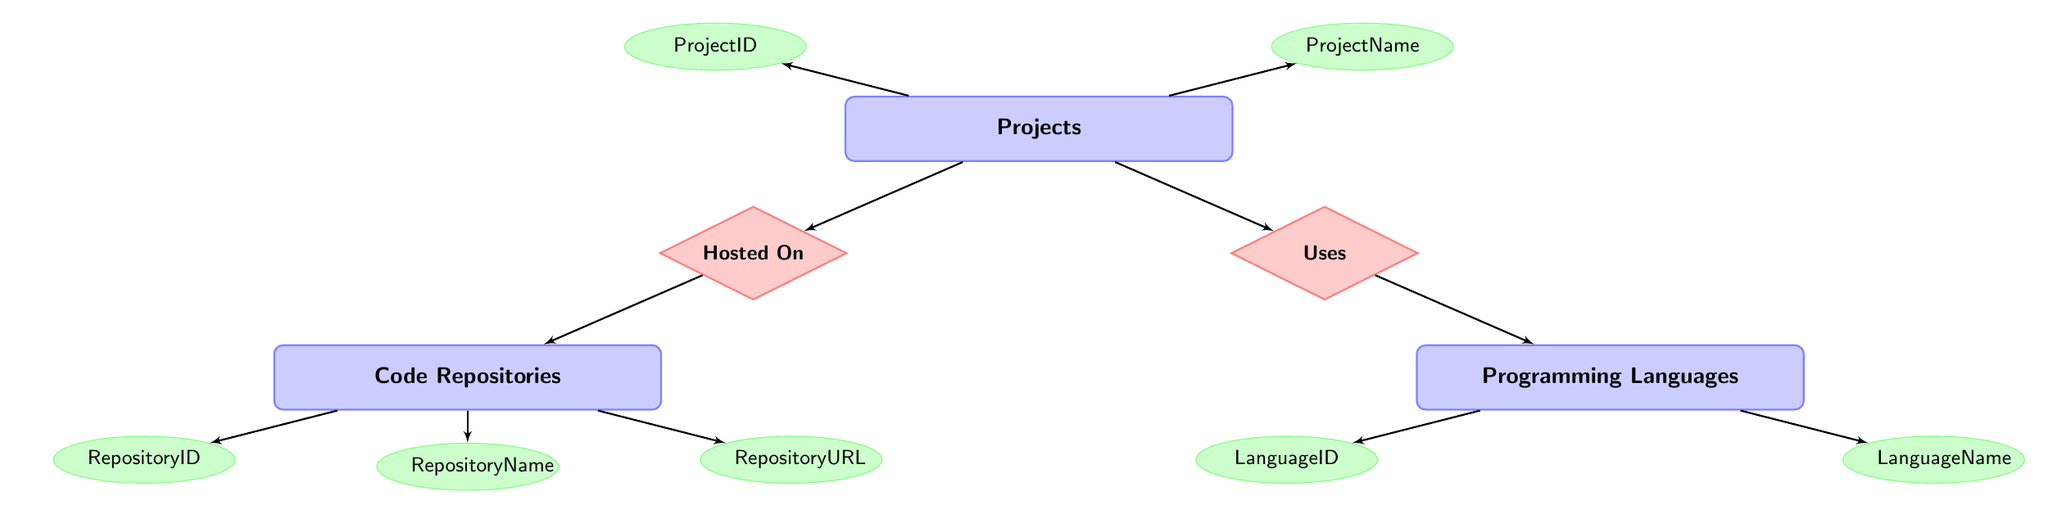What is the ProjectID of the "To-Do List" project? To find the ProjectID for the "To-Do List," I look at the "Projects" entity and find the "ProjectName." The entry for "To-Do List" has a ProjectID of 3.
Answer: 3 Which Programming Language is used in the "Weather App"? To answer this, I refer to the "ProjectsProgrammingLanguages" relationship. I find the entry with ProjectID 2 (which corresponds to "Weather App") and check its associated LanguageID, which is 2. Then, I look in the "Programming Languages" entity for LanguageID 2, finding that it corresponds to "JavaScript."
Answer: JavaScript Where is the "2D RPG Game" project hosted? I look at the "ProjectsCodeRepositories" relationship for ProjectID 1, which is the identifier for the "2D RPG Game." The associated RepositoryID is 1. Then, I check the "Code Repositories" entity and find that RepositoryID 1 corresponds to "GitHub."
Answer: GitHub What Programming Language is used in the project hosted on GitLab? First, I find the repository hosted on GitLab in the "Code Repositories" entity, which has RepositoryID 3. Next, I check the "ProjectsCodeRepositories" relationship for RepositoryID 3 to find the associated ProjectID, which is 3. Finally, I look into the "ProjectsProgrammingLanguages" relationship for ProjectID 3 and see that it uses LanguageID 1, which corresponds to "Python" in the "Programming Languages" entity.
Answer: Python How many entities are represented in this ERD? The entities include "Projects," "Programming Languages," and "Code Repositories." Counting these gives a total of 3 entities.
Answer: 3 Which project uses Python as its programming language? I look at the "ProjectsProgrammingLanguages" relationship and find which LanguageID 1 (Python) corresponds to, which is ProjectID 3. I then refer back to the "Projects" entity, where ProjectID 3 is linked to the "To-Do List" project.
Answer: To-Do List What is the RepositoryURL for the Weather App's hosting? I first identify the "Weather App" in the "Projects" entity, which corresponds to ProjectID 2. Then, I check the "ProjectsCodeRepositories" relationship for ProjectID 2, which points to RepositoryID 2. Finally, I refer to the "Code Repositories" to find RepositoryID 2, which gives the URL "https://bitbucket.org/username/weather-app."
Answer: https://bitbucket.org/username/weather-app What relationship connects Projects and Programming Languages? The connection between "Projects" and "Programming Languages" is defined by the "Uses" relationship. This shows which programming language each project depends on.
Answer: Uses How many programming languages are in the diagram? I count the entries in the "Programming Languages" entity. There are 3 programming languages listed: Python, JavaScript, and C#.
Answer: 3 